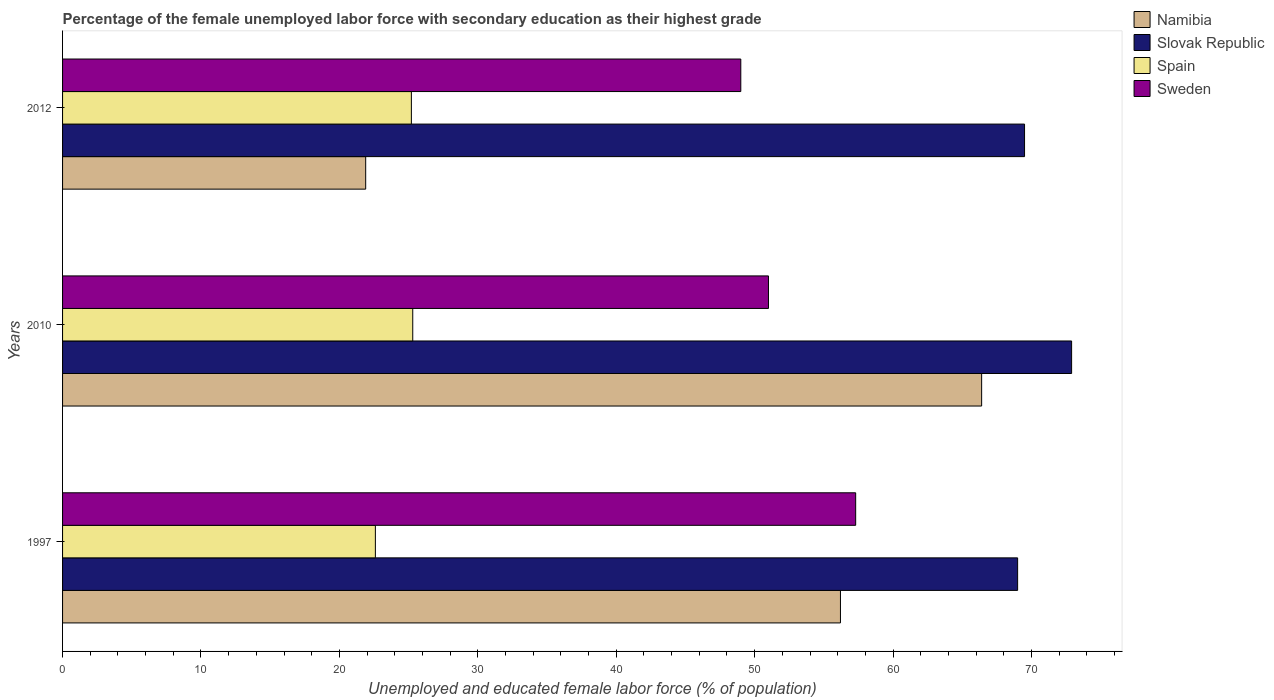How many different coloured bars are there?
Your answer should be compact. 4. How many groups of bars are there?
Your answer should be compact. 3. How many bars are there on the 1st tick from the top?
Offer a very short reply. 4. In how many cases, is the number of bars for a given year not equal to the number of legend labels?
Keep it short and to the point. 0. What is the percentage of the unemployed female labor force with secondary education in Spain in 2012?
Give a very brief answer. 25.2. Across all years, what is the maximum percentage of the unemployed female labor force with secondary education in Namibia?
Keep it short and to the point. 66.4. Across all years, what is the minimum percentage of the unemployed female labor force with secondary education in Namibia?
Provide a succinct answer. 21.9. In which year was the percentage of the unemployed female labor force with secondary education in Slovak Republic maximum?
Your answer should be very brief. 2010. In which year was the percentage of the unemployed female labor force with secondary education in Namibia minimum?
Offer a very short reply. 2012. What is the total percentage of the unemployed female labor force with secondary education in Sweden in the graph?
Offer a very short reply. 157.3. What is the difference between the percentage of the unemployed female labor force with secondary education in Spain in 1997 and that in 2012?
Provide a short and direct response. -2.6. What is the difference between the percentage of the unemployed female labor force with secondary education in Namibia in 2010 and the percentage of the unemployed female labor force with secondary education in Slovak Republic in 1997?
Ensure brevity in your answer.  -2.6. What is the average percentage of the unemployed female labor force with secondary education in Namibia per year?
Offer a terse response. 48.17. In the year 2010, what is the difference between the percentage of the unemployed female labor force with secondary education in Slovak Republic and percentage of the unemployed female labor force with secondary education in Namibia?
Provide a short and direct response. 6.5. What is the ratio of the percentage of the unemployed female labor force with secondary education in Sweden in 1997 to that in 2010?
Provide a short and direct response. 1.12. Is the difference between the percentage of the unemployed female labor force with secondary education in Slovak Republic in 2010 and 2012 greater than the difference between the percentage of the unemployed female labor force with secondary education in Namibia in 2010 and 2012?
Offer a very short reply. No. What is the difference between the highest and the second highest percentage of the unemployed female labor force with secondary education in Namibia?
Your answer should be compact. 10.2. What is the difference between the highest and the lowest percentage of the unemployed female labor force with secondary education in Namibia?
Ensure brevity in your answer.  44.5. In how many years, is the percentage of the unemployed female labor force with secondary education in Namibia greater than the average percentage of the unemployed female labor force with secondary education in Namibia taken over all years?
Offer a very short reply. 2. Is the sum of the percentage of the unemployed female labor force with secondary education in Namibia in 2010 and 2012 greater than the maximum percentage of the unemployed female labor force with secondary education in Sweden across all years?
Your answer should be compact. Yes. Is it the case that in every year, the sum of the percentage of the unemployed female labor force with secondary education in Spain and percentage of the unemployed female labor force with secondary education in Sweden is greater than the sum of percentage of the unemployed female labor force with secondary education in Namibia and percentage of the unemployed female labor force with secondary education in Slovak Republic?
Your answer should be very brief. No. What does the 1st bar from the top in 1997 represents?
Make the answer very short. Sweden. What does the 3rd bar from the bottom in 1997 represents?
Provide a succinct answer. Spain. Are all the bars in the graph horizontal?
Provide a short and direct response. Yes. Are the values on the major ticks of X-axis written in scientific E-notation?
Give a very brief answer. No. Does the graph contain any zero values?
Make the answer very short. No. Does the graph contain grids?
Ensure brevity in your answer.  No. Where does the legend appear in the graph?
Your answer should be compact. Top right. How are the legend labels stacked?
Offer a terse response. Vertical. What is the title of the graph?
Your response must be concise. Percentage of the female unemployed labor force with secondary education as their highest grade. Does "Jamaica" appear as one of the legend labels in the graph?
Ensure brevity in your answer.  No. What is the label or title of the X-axis?
Your response must be concise. Unemployed and educated female labor force (% of population). What is the label or title of the Y-axis?
Keep it short and to the point. Years. What is the Unemployed and educated female labor force (% of population) in Namibia in 1997?
Offer a terse response. 56.2. What is the Unemployed and educated female labor force (% of population) in Spain in 1997?
Provide a succinct answer. 22.6. What is the Unemployed and educated female labor force (% of population) of Sweden in 1997?
Offer a very short reply. 57.3. What is the Unemployed and educated female labor force (% of population) of Namibia in 2010?
Your response must be concise. 66.4. What is the Unemployed and educated female labor force (% of population) of Slovak Republic in 2010?
Your answer should be very brief. 72.9. What is the Unemployed and educated female labor force (% of population) of Spain in 2010?
Provide a succinct answer. 25.3. What is the Unemployed and educated female labor force (% of population) of Sweden in 2010?
Ensure brevity in your answer.  51. What is the Unemployed and educated female labor force (% of population) in Namibia in 2012?
Your response must be concise. 21.9. What is the Unemployed and educated female labor force (% of population) of Slovak Republic in 2012?
Ensure brevity in your answer.  69.5. What is the Unemployed and educated female labor force (% of population) of Spain in 2012?
Give a very brief answer. 25.2. Across all years, what is the maximum Unemployed and educated female labor force (% of population) in Namibia?
Give a very brief answer. 66.4. Across all years, what is the maximum Unemployed and educated female labor force (% of population) in Slovak Republic?
Give a very brief answer. 72.9. Across all years, what is the maximum Unemployed and educated female labor force (% of population) in Spain?
Provide a succinct answer. 25.3. Across all years, what is the maximum Unemployed and educated female labor force (% of population) of Sweden?
Provide a succinct answer. 57.3. Across all years, what is the minimum Unemployed and educated female labor force (% of population) of Namibia?
Give a very brief answer. 21.9. Across all years, what is the minimum Unemployed and educated female labor force (% of population) in Slovak Republic?
Ensure brevity in your answer.  69. Across all years, what is the minimum Unemployed and educated female labor force (% of population) of Spain?
Your answer should be compact. 22.6. Across all years, what is the minimum Unemployed and educated female labor force (% of population) of Sweden?
Your answer should be compact. 49. What is the total Unemployed and educated female labor force (% of population) in Namibia in the graph?
Make the answer very short. 144.5. What is the total Unemployed and educated female labor force (% of population) in Slovak Republic in the graph?
Provide a short and direct response. 211.4. What is the total Unemployed and educated female labor force (% of population) in Spain in the graph?
Your answer should be very brief. 73.1. What is the total Unemployed and educated female labor force (% of population) in Sweden in the graph?
Offer a terse response. 157.3. What is the difference between the Unemployed and educated female labor force (% of population) of Namibia in 1997 and that in 2010?
Offer a terse response. -10.2. What is the difference between the Unemployed and educated female labor force (% of population) in Slovak Republic in 1997 and that in 2010?
Provide a succinct answer. -3.9. What is the difference between the Unemployed and educated female labor force (% of population) in Namibia in 1997 and that in 2012?
Provide a short and direct response. 34.3. What is the difference between the Unemployed and educated female labor force (% of population) of Namibia in 2010 and that in 2012?
Your response must be concise. 44.5. What is the difference between the Unemployed and educated female labor force (% of population) of Namibia in 1997 and the Unemployed and educated female labor force (% of population) of Slovak Republic in 2010?
Keep it short and to the point. -16.7. What is the difference between the Unemployed and educated female labor force (% of population) of Namibia in 1997 and the Unemployed and educated female labor force (% of population) of Spain in 2010?
Offer a very short reply. 30.9. What is the difference between the Unemployed and educated female labor force (% of population) of Namibia in 1997 and the Unemployed and educated female labor force (% of population) of Sweden in 2010?
Make the answer very short. 5.2. What is the difference between the Unemployed and educated female labor force (% of population) in Slovak Republic in 1997 and the Unemployed and educated female labor force (% of population) in Spain in 2010?
Your response must be concise. 43.7. What is the difference between the Unemployed and educated female labor force (% of population) in Slovak Republic in 1997 and the Unemployed and educated female labor force (% of population) in Sweden in 2010?
Keep it short and to the point. 18. What is the difference between the Unemployed and educated female labor force (% of population) of Spain in 1997 and the Unemployed and educated female labor force (% of population) of Sweden in 2010?
Your answer should be very brief. -28.4. What is the difference between the Unemployed and educated female labor force (% of population) of Namibia in 1997 and the Unemployed and educated female labor force (% of population) of Sweden in 2012?
Your answer should be compact. 7.2. What is the difference between the Unemployed and educated female labor force (% of population) of Slovak Republic in 1997 and the Unemployed and educated female labor force (% of population) of Spain in 2012?
Your answer should be very brief. 43.8. What is the difference between the Unemployed and educated female labor force (% of population) of Slovak Republic in 1997 and the Unemployed and educated female labor force (% of population) of Sweden in 2012?
Your response must be concise. 20. What is the difference between the Unemployed and educated female labor force (% of population) of Spain in 1997 and the Unemployed and educated female labor force (% of population) of Sweden in 2012?
Offer a terse response. -26.4. What is the difference between the Unemployed and educated female labor force (% of population) of Namibia in 2010 and the Unemployed and educated female labor force (% of population) of Slovak Republic in 2012?
Ensure brevity in your answer.  -3.1. What is the difference between the Unemployed and educated female labor force (% of population) of Namibia in 2010 and the Unemployed and educated female labor force (% of population) of Spain in 2012?
Offer a terse response. 41.2. What is the difference between the Unemployed and educated female labor force (% of population) in Slovak Republic in 2010 and the Unemployed and educated female labor force (% of population) in Spain in 2012?
Your answer should be compact. 47.7. What is the difference between the Unemployed and educated female labor force (% of population) of Slovak Republic in 2010 and the Unemployed and educated female labor force (% of population) of Sweden in 2012?
Ensure brevity in your answer.  23.9. What is the difference between the Unemployed and educated female labor force (% of population) of Spain in 2010 and the Unemployed and educated female labor force (% of population) of Sweden in 2012?
Ensure brevity in your answer.  -23.7. What is the average Unemployed and educated female labor force (% of population) in Namibia per year?
Provide a short and direct response. 48.17. What is the average Unemployed and educated female labor force (% of population) of Slovak Republic per year?
Your answer should be very brief. 70.47. What is the average Unemployed and educated female labor force (% of population) of Spain per year?
Give a very brief answer. 24.37. What is the average Unemployed and educated female labor force (% of population) of Sweden per year?
Make the answer very short. 52.43. In the year 1997, what is the difference between the Unemployed and educated female labor force (% of population) in Namibia and Unemployed and educated female labor force (% of population) in Spain?
Your answer should be compact. 33.6. In the year 1997, what is the difference between the Unemployed and educated female labor force (% of population) of Namibia and Unemployed and educated female labor force (% of population) of Sweden?
Your answer should be compact. -1.1. In the year 1997, what is the difference between the Unemployed and educated female labor force (% of population) of Slovak Republic and Unemployed and educated female labor force (% of population) of Spain?
Your response must be concise. 46.4. In the year 1997, what is the difference between the Unemployed and educated female labor force (% of population) in Slovak Republic and Unemployed and educated female labor force (% of population) in Sweden?
Ensure brevity in your answer.  11.7. In the year 1997, what is the difference between the Unemployed and educated female labor force (% of population) in Spain and Unemployed and educated female labor force (% of population) in Sweden?
Offer a terse response. -34.7. In the year 2010, what is the difference between the Unemployed and educated female labor force (% of population) of Namibia and Unemployed and educated female labor force (% of population) of Spain?
Keep it short and to the point. 41.1. In the year 2010, what is the difference between the Unemployed and educated female labor force (% of population) in Slovak Republic and Unemployed and educated female labor force (% of population) in Spain?
Give a very brief answer. 47.6. In the year 2010, what is the difference between the Unemployed and educated female labor force (% of population) of Slovak Republic and Unemployed and educated female labor force (% of population) of Sweden?
Provide a succinct answer. 21.9. In the year 2010, what is the difference between the Unemployed and educated female labor force (% of population) in Spain and Unemployed and educated female labor force (% of population) in Sweden?
Your answer should be compact. -25.7. In the year 2012, what is the difference between the Unemployed and educated female labor force (% of population) of Namibia and Unemployed and educated female labor force (% of population) of Slovak Republic?
Offer a terse response. -47.6. In the year 2012, what is the difference between the Unemployed and educated female labor force (% of population) of Namibia and Unemployed and educated female labor force (% of population) of Spain?
Provide a short and direct response. -3.3. In the year 2012, what is the difference between the Unemployed and educated female labor force (% of population) of Namibia and Unemployed and educated female labor force (% of population) of Sweden?
Provide a succinct answer. -27.1. In the year 2012, what is the difference between the Unemployed and educated female labor force (% of population) of Slovak Republic and Unemployed and educated female labor force (% of population) of Spain?
Give a very brief answer. 44.3. In the year 2012, what is the difference between the Unemployed and educated female labor force (% of population) in Spain and Unemployed and educated female labor force (% of population) in Sweden?
Give a very brief answer. -23.8. What is the ratio of the Unemployed and educated female labor force (% of population) of Namibia in 1997 to that in 2010?
Give a very brief answer. 0.85. What is the ratio of the Unemployed and educated female labor force (% of population) in Slovak Republic in 1997 to that in 2010?
Your answer should be very brief. 0.95. What is the ratio of the Unemployed and educated female labor force (% of population) in Spain in 1997 to that in 2010?
Provide a short and direct response. 0.89. What is the ratio of the Unemployed and educated female labor force (% of population) in Sweden in 1997 to that in 2010?
Offer a very short reply. 1.12. What is the ratio of the Unemployed and educated female labor force (% of population) of Namibia in 1997 to that in 2012?
Ensure brevity in your answer.  2.57. What is the ratio of the Unemployed and educated female labor force (% of population) in Slovak Republic in 1997 to that in 2012?
Ensure brevity in your answer.  0.99. What is the ratio of the Unemployed and educated female labor force (% of population) of Spain in 1997 to that in 2012?
Keep it short and to the point. 0.9. What is the ratio of the Unemployed and educated female labor force (% of population) in Sweden in 1997 to that in 2012?
Your answer should be compact. 1.17. What is the ratio of the Unemployed and educated female labor force (% of population) in Namibia in 2010 to that in 2012?
Offer a terse response. 3.03. What is the ratio of the Unemployed and educated female labor force (% of population) in Slovak Republic in 2010 to that in 2012?
Offer a very short reply. 1.05. What is the ratio of the Unemployed and educated female labor force (% of population) in Sweden in 2010 to that in 2012?
Offer a terse response. 1.04. What is the difference between the highest and the second highest Unemployed and educated female labor force (% of population) of Slovak Republic?
Your answer should be very brief. 3.4. What is the difference between the highest and the lowest Unemployed and educated female labor force (% of population) in Namibia?
Ensure brevity in your answer.  44.5. What is the difference between the highest and the lowest Unemployed and educated female labor force (% of population) in Slovak Republic?
Your answer should be compact. 3.9. What is the difference between the highest and the lowest Unemployed and educated female labor force (% of population) in Sweden?
Keep it short and to the point. 8.3. 